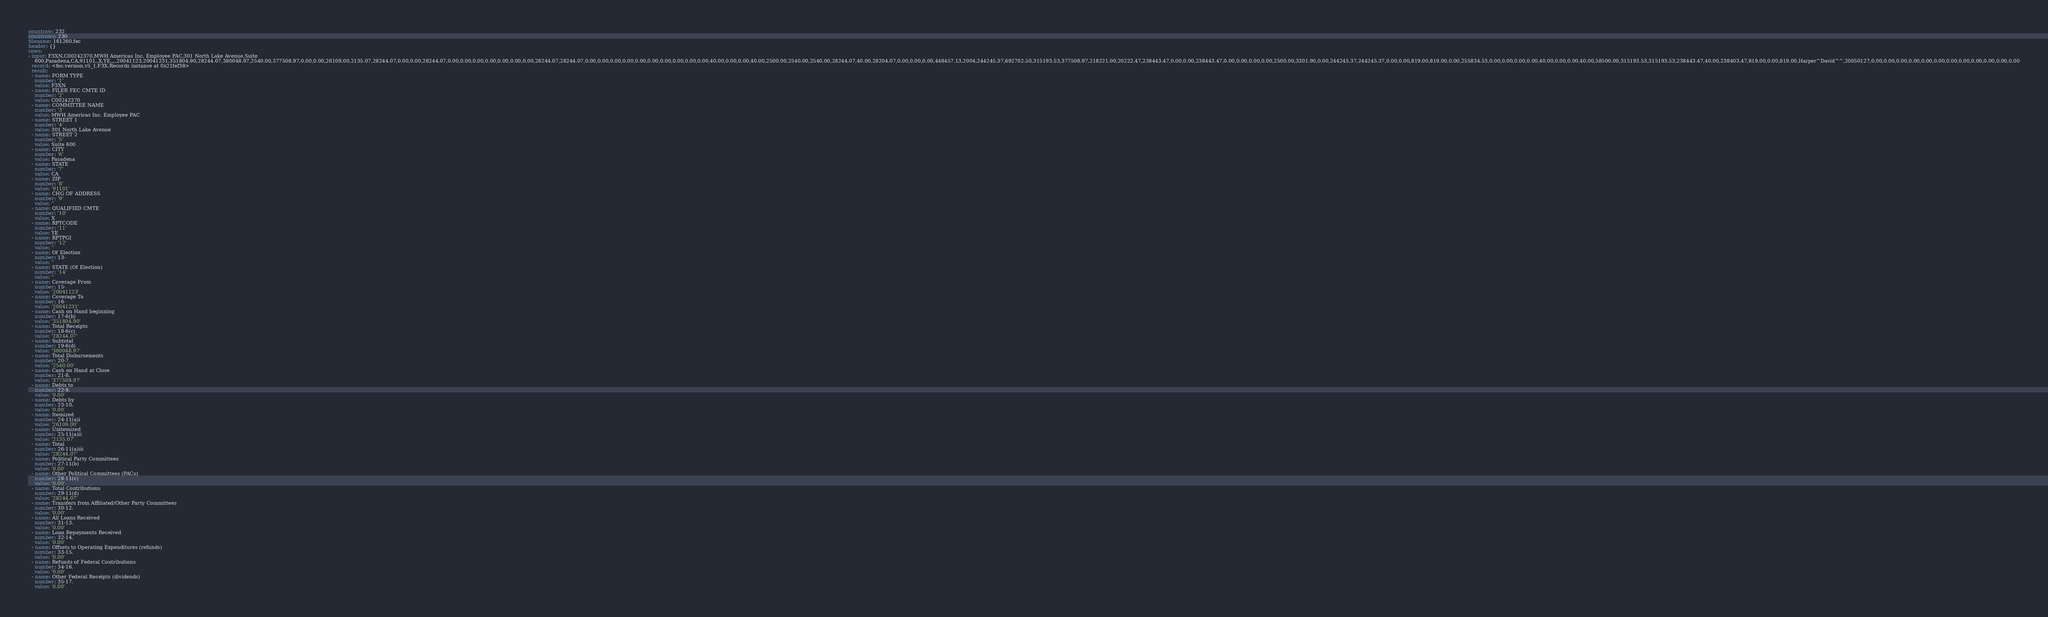Convert code to text. <code><loc_0><loc_0><loc_500><loc_500><_YAML_>countraw: 232
countrows: 230
filename: 161260.fec
header: {}
rows:
- input: F3XN,C00242370,MWH Americas Inc. Employee PAC,301 North Lake Avenue,Suite
    600,Pasadena,CA,91101,,X,YE,,,,20041123,20041231,351804.90,28244.07,380048.97,2540.00,377508.97,0.00,0.00,26109.00,2135.07,28244.07,0.00,0.00,28244.07,0.00,0.00,0.00,0.00,0.00,0.00,0.00,28244.07,28244.07,0.00,0.00,0.00,0.00,0.00,0.00,0.00,0.00,0.00,0.00,40.00,0.00,0.00,40.00,2500.00,2540.00,2540.00,28244.07,40.00,28204.07,0.00,0.00,0.00,448457.13,2004,244245.37,692702.50,315193.53,377508.97,218221.00,20222.47,238443.47,0.00,0.00,238443.47,0.00,0.00,0.00,0.00,2500.00,3301.90,0.00,244245.37,244245.37,0.00,0.00,819.00,819.00,0.00,255834.53,0.00,0.00,0.00,0.00,40.00,0.00,0.00,40.00,58500.00,315193.53,315193.53,238443.47,40.00,238403.47,819.00,0.00,819.00,Harper^David^^,20050127,0.00,0.00,0.00,0.00,0.00,0.00,0.00,0.00,0.00,0.00,0.00,0.00
  record: <fec.version.v5_1.F3X.Records instance at 0x21fef38>
  result:
  - name: FORM TYPE
    number: '1'
    value: F3XN
  - name: FILER FEC CMTE ID
    number: '2'
    value: C00242370
  - name: COMMITTEE NAME
    number: '3'
    value: MWH Americas Inc. Employee PAC
  - name: STREET 1
    number: '4'
    value: 301 North Lake Avenue
  - name: STREET 2
    number: '5'
    value: Suite 600
  - name: CITY
    number: '6'
    value: Pasadena
  - name: STATE
    number: '7'
    value: CA
  - name: ZIP
    number: '8'
    value: '91101'
  - name: CHG OF ADDRESS
    number: '9'
    value: ''
  - name: QUALIFIED CMTE
    number: '10'
    value: X
  - name: RPTCODE
    number: '11'
    value: YE
  - name: RPTPGI
    number: '12'
    value: ''
  - name: Of Election
    number: 13-
    value: ''
  - name: STATE (Of Election)
    number: '14'
    value: ''
  - name: Coverage From
    number: 15-
    value: '20041123'
  - name: Coverage To
    number: 16-
    value: '20041231'
  - name: Cash on Hand beginning
    number: 17-6(b)
    value: '351804.90'
  - name: Total Receipts
    number: 18-6(c)
    value: '28244.07'
  - name: Subtotal
    number: 19-6(d)
    value: '380048.97'
  - name: Total Disbursements
    number: 20-7.
    value: '2540.00'
  - name: Cash on Hand at Close
    number: 21-8.
    value: '377508.97'
  - name: Debts to
    number: 22-9.
    value: '0.00'
  - name: Debts by
    number: 23-10.
    value: '0.00'
  - name: Itemized
    number: 24-11(a)i
    value: '26109.00'
  - name: Unitemized
    number: 25-11(a)ii
    value: '2135.07'
  - name: Total
    number: 26-11(a)iii
    value: '28244.07'
  - name: Political Party Committees
    number: 27-11(b)
    value: '0.00'
  - name: Other Political Committees (PACs)
    number: 28-11(c)
    value: '0.00'
  - name: Total Contributions
    number: 29-11(d)
    value: '28244.07'
  - name: Transfers from Affiliated/Other Party Committees
    number: 30-12.
    value: '0.00'
  - name: All Loans Received
    number: 31-13.
    value: '0.00'
  - name: Loan Repayments Received
    number: 32-14.
    value: '0.00'
  - name: Offsets to Operating Expenditures (refunds)
    number: 33-15.
    value: '0.00'
  - name: Refunds of Federal Contributions
    number: 34-16.
    value: '0.00'
  - name: Other Federal Receipts (dividends)
    number: 35-17.
    value: '0.00'</code> 